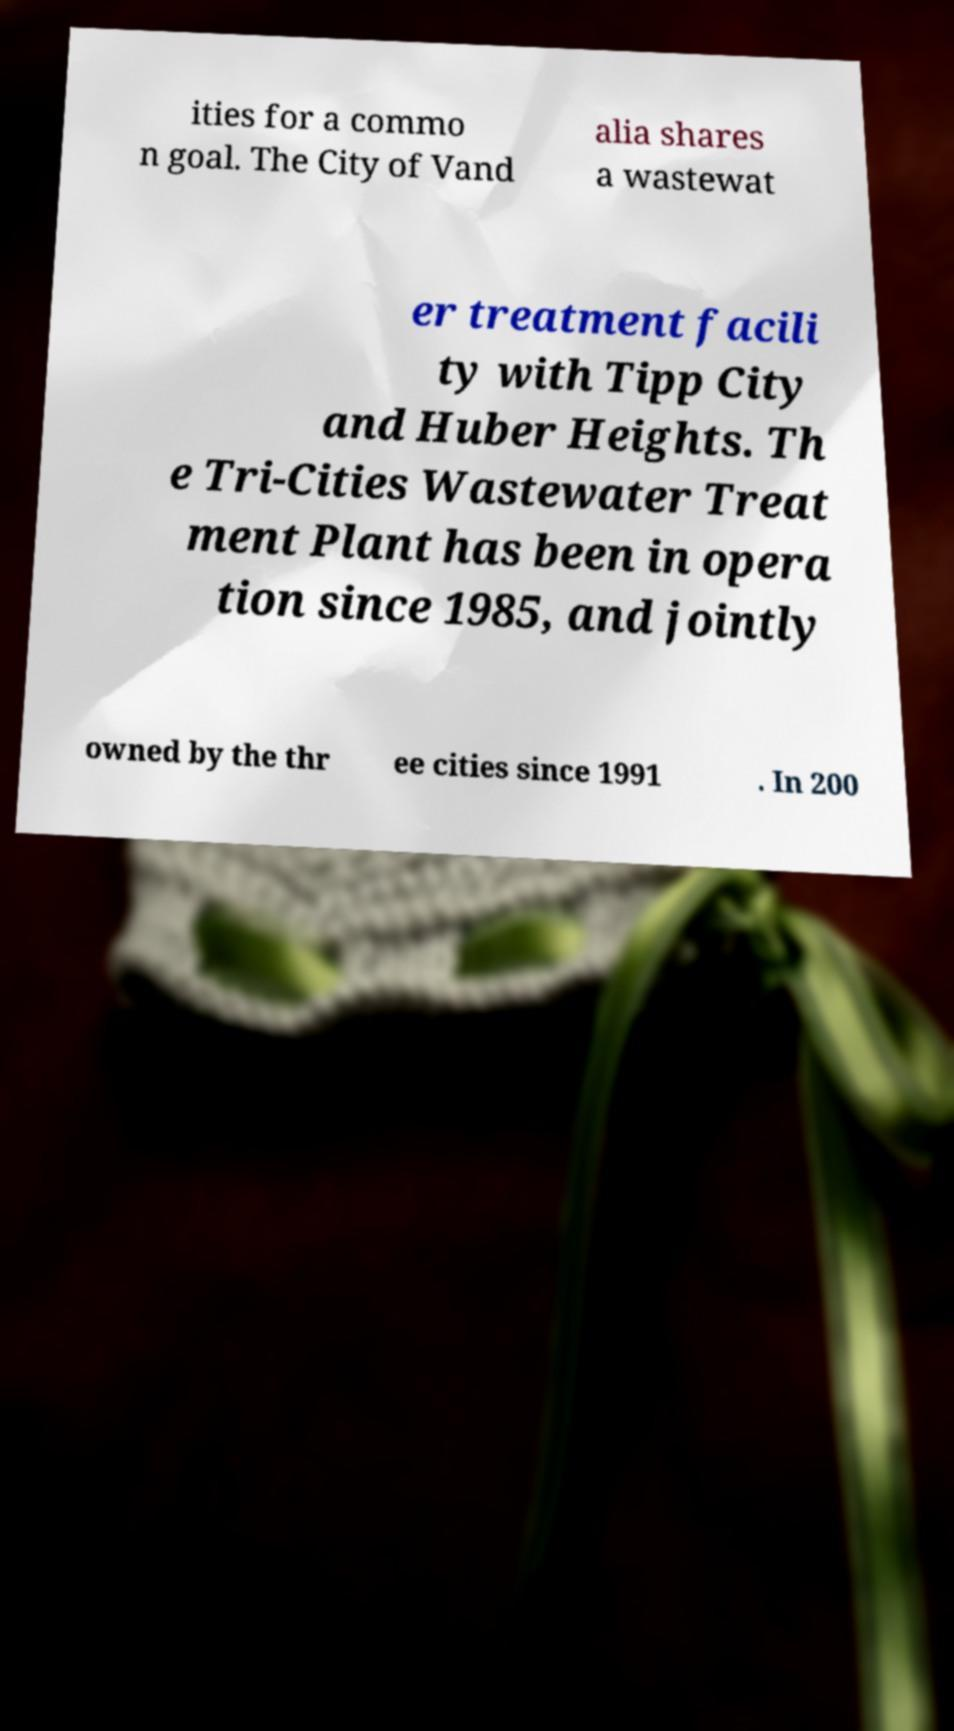Please read and relay the text visible in this image. What does it say? ities for a commo n goal. The City of Vand alia shares a wastewat er treatment facili ty with Tipp City and Huber Heights. Th e Tri-Cities Wastewater Treat ment Plant has been in opera tion since 1985, and jointly owned by the thr ee cities since 1991 . In 200 